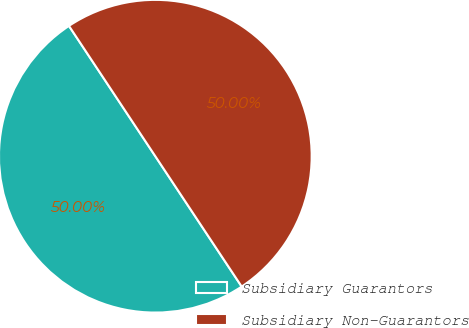Convert chart to OTSL. <chart><loc_0><loc_0><loc_500><loc_500><pie_chart><fcel>Subsidiary Guarantors<fcel>Subsidiary Non-Guarantors<nl><fcel>50.0%<fcel>50.0%<nl></chart> 